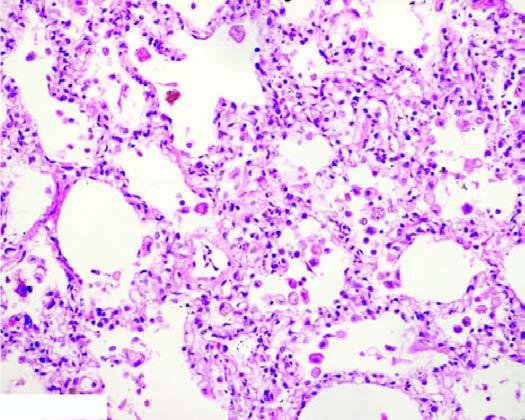what are widened and thickened due to congestion, oedema and mild fibrosis?
Answer the question using a single word or phrase. The alveolar septa 